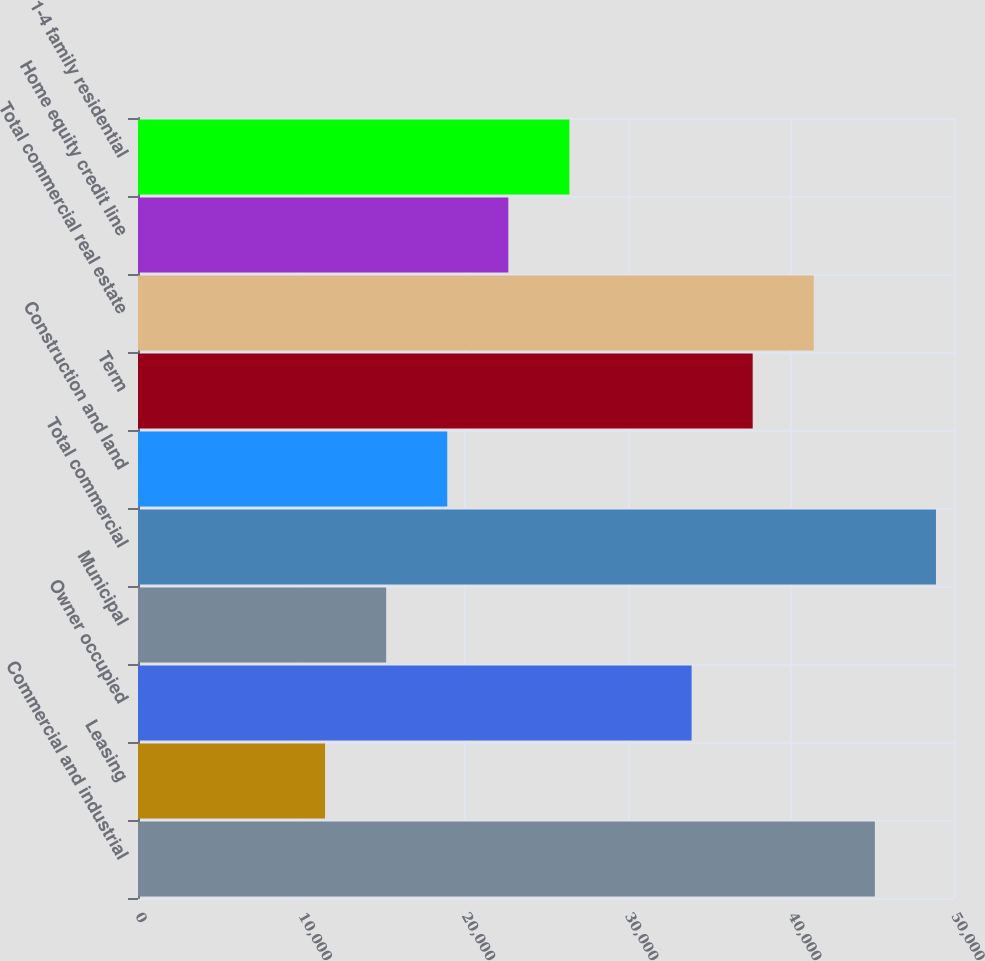Convert chart to OTSL. <chart><loc_0><loc_0><loc_500><loc_500><bar_chart><fcel>Commercial and industrial<fcel>Leasing<fcel>Owner occupied<fcel>Municipal<fcel>Total commercial<fcel>Construction and land<fcel>Term<fcel>Total commercial real estate<fcel>Home equity credit line<fcel>1-4 family residential<nl><fcel>45151.4<fcel>11462.6<fcel>33921.8<fcel>15205.8<fcel>48894.6<fcel>18949<fcel>37665<fcel>41408.2<fcel>22692.2<fcel>26435.4<nl></chart> 